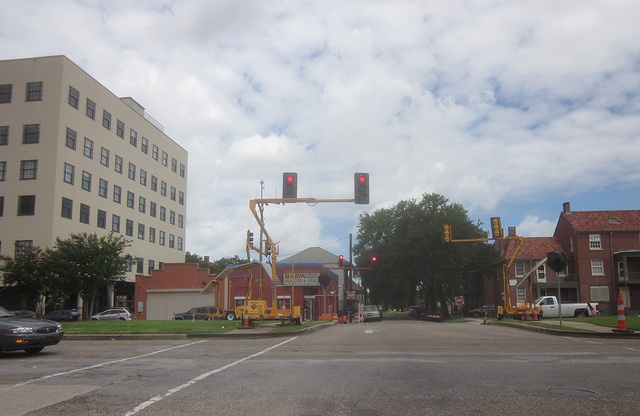Describe the objects in this image and their specific colors. I can see car in lightgray, black, gray, and darkgray tones, truck in lightgray, gray, darkgray, black, and maroon tones, traffic light in lightgray, gray, darkgray, and salmon tones, car in lightgray, gray, and black tones, and car in lightgray, gray, black, and darkgreen tones in this image. 